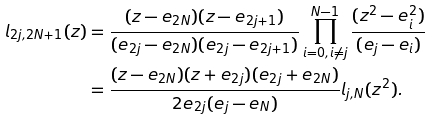Convert formula to latex. <formula><loc_0><loc_0><loc_500><loc_500>l _ { 2 j , 2 N + 1 } ( z ) & = \frac { ( z - e _ { 2 N } ) ( z - e _ { 2 j + 1 } ) } { ( e _ { 2 j } - e _ { 2 N } ) ( e _ { 2 j } - e _ { 2 j + 1 } ) } \prod _ { i = 0 , i \not = j } ^ { N - 1 } \frac { ( z ^ { 2 } - e _ { i } ^ { 2 } ) } { ( e _ { j } - e _ { i } ) } \\ & = \frac { ( z - e _ { 2 N } ) ( z + e _ { 2 j } ) ( e _ { 2 j } + e _ { 2 N } ) } { 2 e _ { 2 j } ( e _ { j } - e _ { N } ) } l _ { j , N } ( z ^ { 2 } ) . \\</formula> 